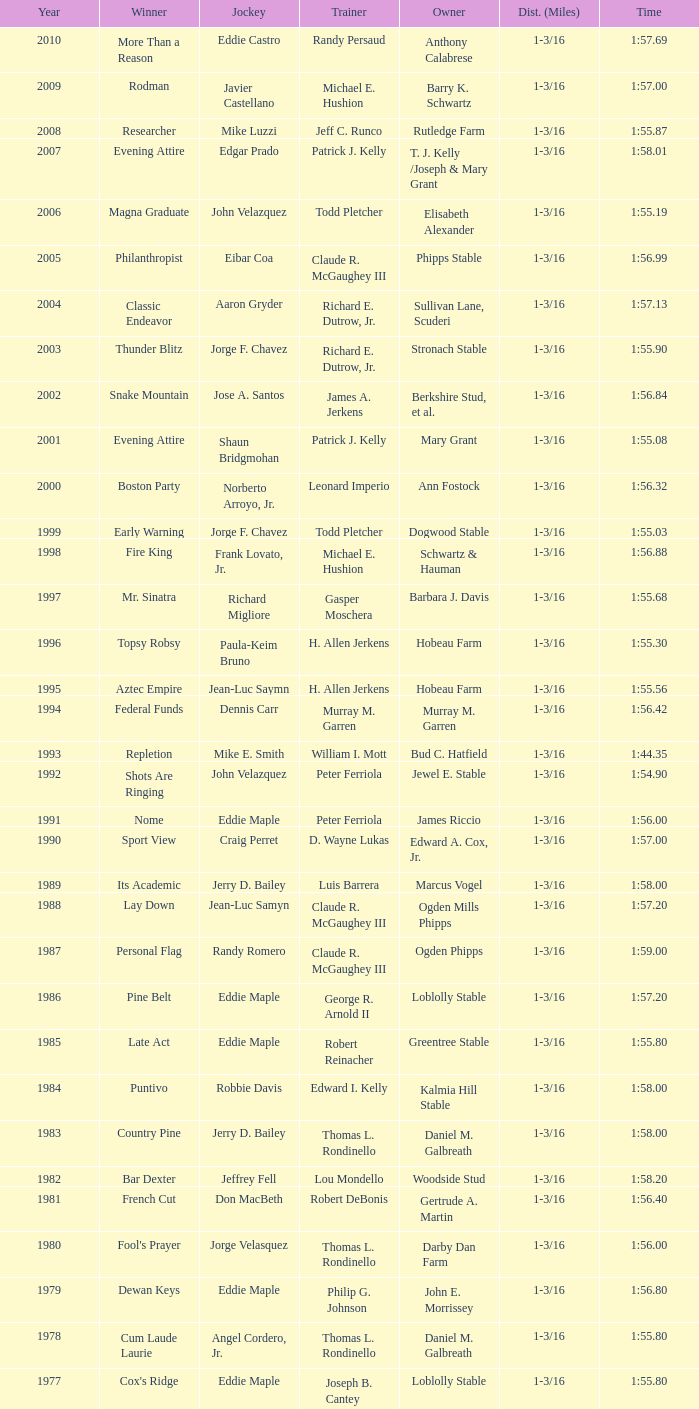What was the winning time for the winning horse, Kentucky ii? 1:38.80. 